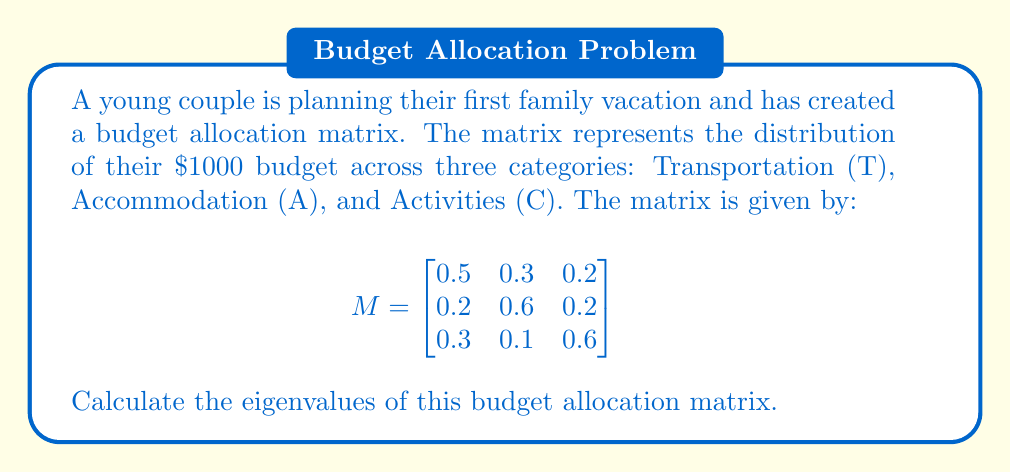Teach me how to tackle this problem. To find the eigenvalues of the matrix M, we need to solve the characteristic equation:

$det(M - \lambda I) = 0$

where $I$ is the 3x3 identity matrix and $\lambda$ represents the eigenvalues.

Step 1: Set up the characteristic equation:
$$
det\begin{pmatrix}
0.5-\lambda & 0.3 & 0.2 \\
0.2 & 0.6-\lambda & 0.2 \\
0.3 & 0.1 & 0.6-\lambda
\end{pmatrix} = 0
$$

Step 2: Expand the determinant:
$$(0.5-\lambda)[(0.6-\lambda)(0.6-\lambda)-0.02] - 0.3[0.2(0.6-\lambda)-0.06] + 0.2[0.06-0.3(0.6-\lambda)] = 0$$

Step 3: Simplify:
$$\lambda^3 - 1.7\lambda^2 + 0.86\lambda - 0.13 = 0$$

Step 4: Solve the cubic equation. This can be done using the cubic formula or numerical methods. Using a computer algebra system, we find the roots of this equation.
Answer: $\lambda_1 \approx 1$, $\lambda_2 \approx 0.4859$, $\lambda_3 \approx 0.2141$ 